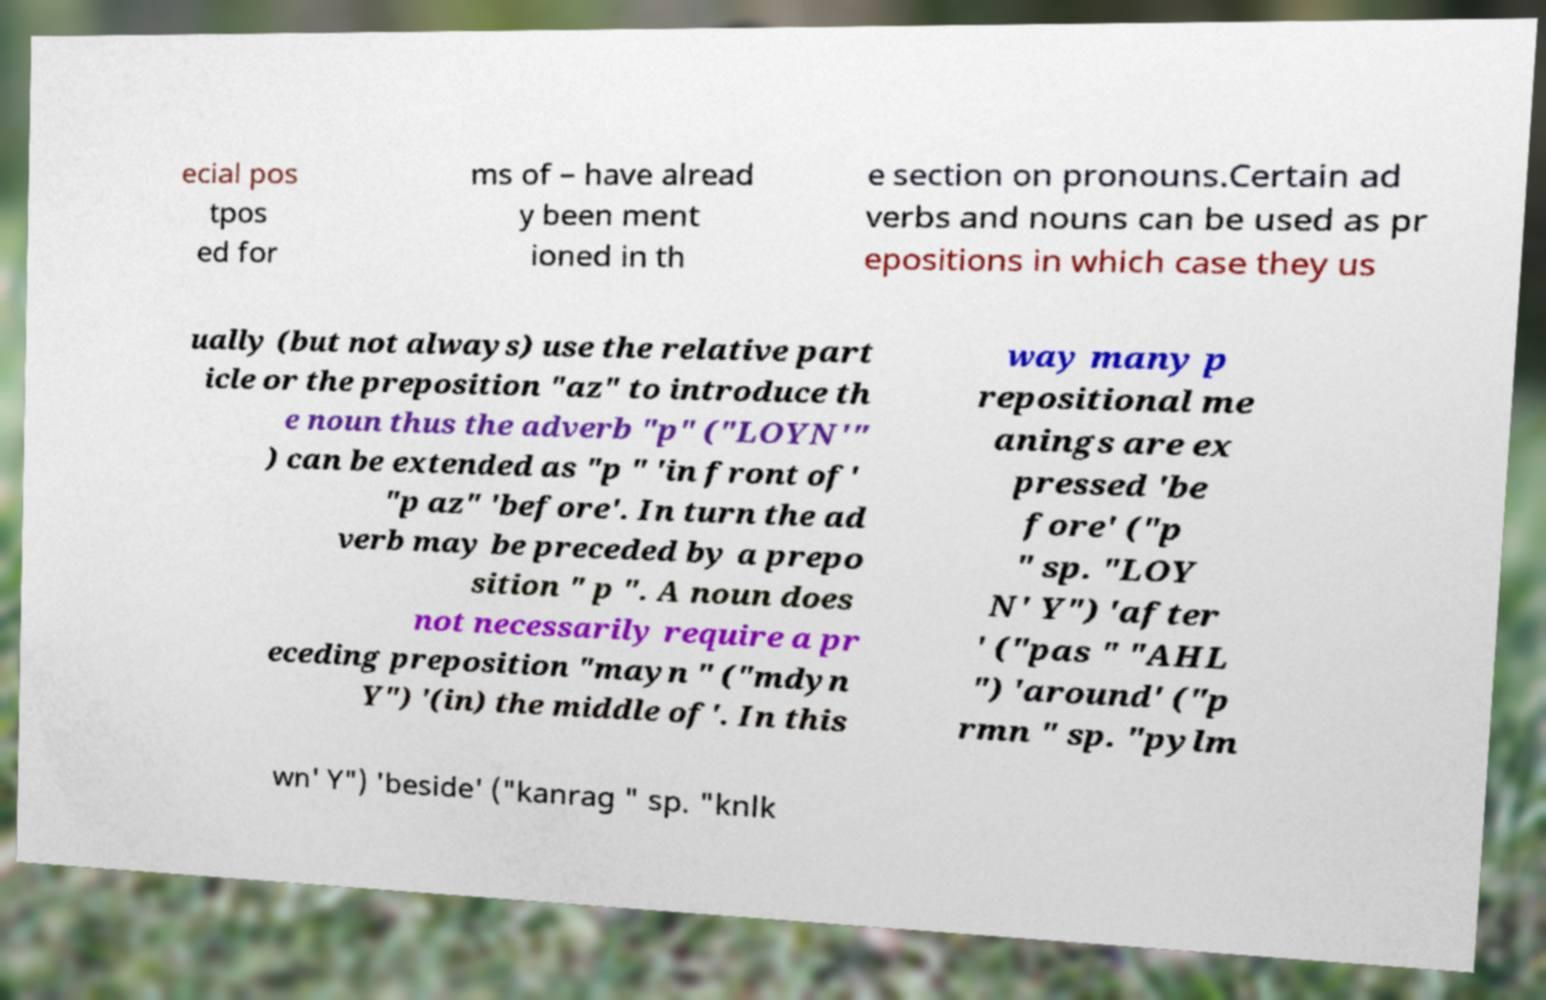There's text embedded in this image that I need extracted. Can you transcribe it verbatim? ecial pos tpos ed for ms of – have alread y been ment ioned in th e section on pronouns.Certain ad verbs and nouns can be used as pr epositions in which case they us ually (but not always) use the relative part icle or the preposition "az" to introduce th e noun thus the adverb "p" ("LOYN'" ) can be extended as "p " 'in front of' "p az" 'before'. In turn the ad verb may be preceded by a prepo sition " p ". A noun does not necessarily require a pr eceding preposition "mayn " ("mdyn Y") '(in) the middle of'. In this way many p repositional me anings are ex pressed 'be fore' ("p " sp. "LOY N' Y") 'after ' ("pas " "AHL ") 'around' ("p rmn " sp. "pylm wn' Y") 'beside' ("kanrag " sp. "knlk 